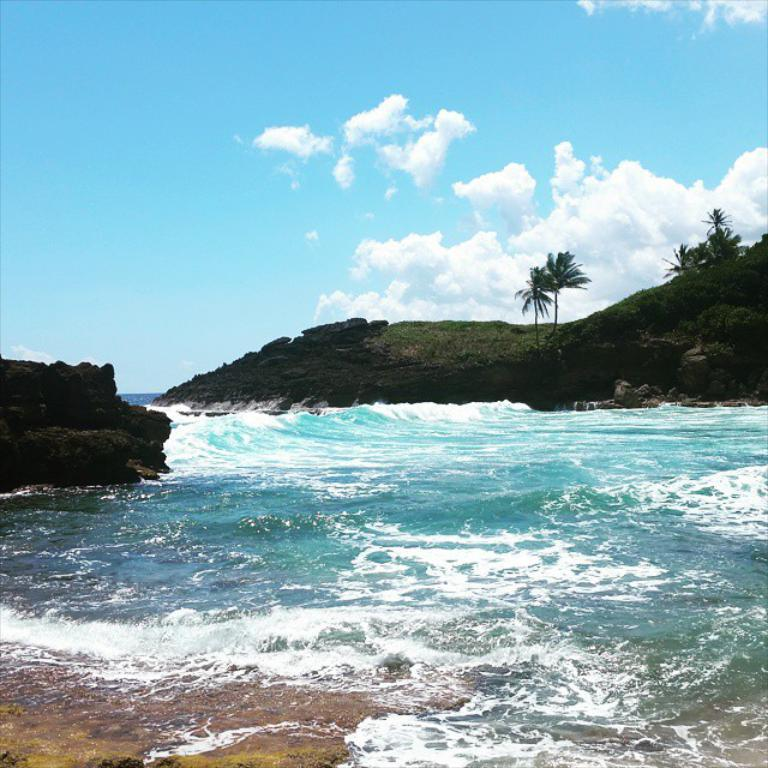What can be seen in the sky in the image? The sky is visible in the image, and clouds are present. What type of natural environment is depicted in the image? The image features trees, hills, rocks, and the sea. Can you describe the terrain in the image? The terrain includes hills and rocks. What body of water is visible in the image? The sea is visible in the image. What type of sign can be seen expressing shame in the image? There is no sign expressing shame present in the image. What emotion is depicted on the rocks in the image? The rocks in the image do not depict any emotions; they are inanimate objects. 